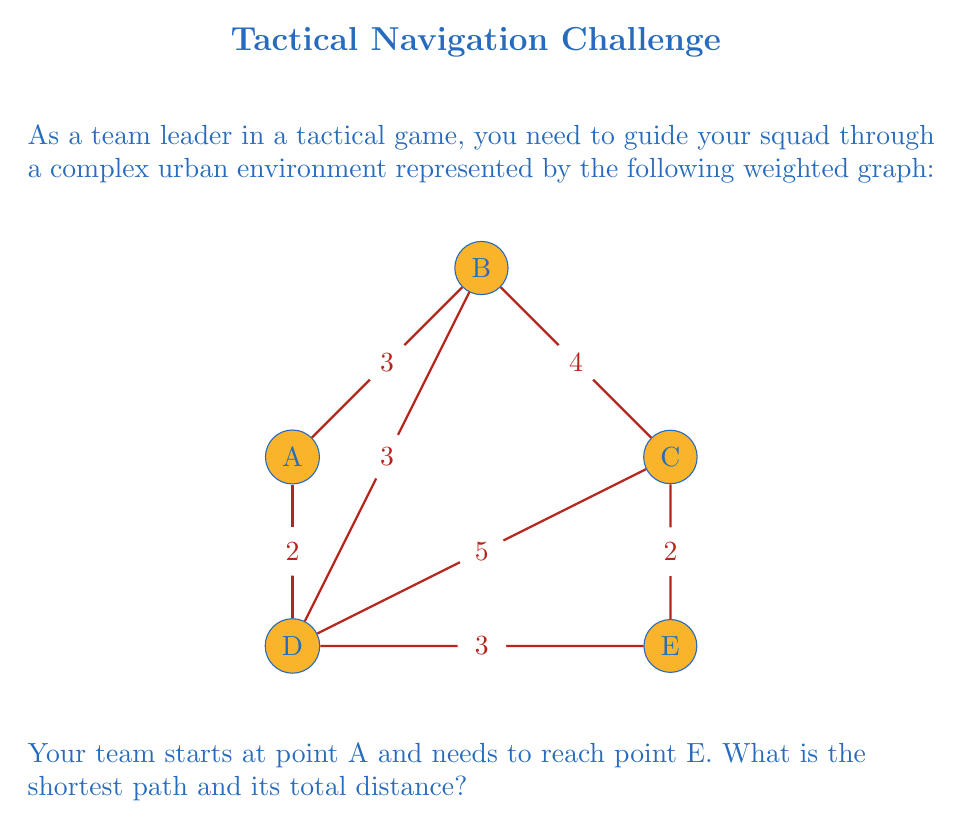Could you help me with this problem? To solve this problem, we'll use Dijkstra's algorithm, which is an efficient method for finding the shortest path in a weighted graph.

Step 1: Initialize the algorithm
- Set distance to A as 0 and all other nodes as infinity.
- Set A as the current node.

Step 2: Update distances to neighboring nodes
- From A: B (3), D (2)
- Update: A(0), B(3), C(∞), D(2), E(∞)

Step 3: Move to the node with the smallest distance (D)
- Update distances from D:
  - To B: min(3, 2+3) = 3 (no change)
  - To C: min(∞, 2+5) = 7
  - To E: min(∞, 2+3) = 5
- Update: A(0), B(3), C(7), D(2), E(5)

Step 4: Move to the next smallest distance (B)
- Update distances from B:
  - To C: min(7, 3+4) = 7 (no change)
- No changes to distances

Step 5: Move to the next smallest distance (E)
- E is our target node, so we stop here.

The shortest path is A → D → E with a total distance of 5.

To verify:
A → B → C → E = 3 + 4 + 2 = 9
A → D → C → E = 2 + 5 + 2 = 9
A → B → D → E = 3 + 3 + 3 = 9
A → D → E = 2 + 3 = 5 (shortest)
Answer: Path: A → D → E; Distance: 5 